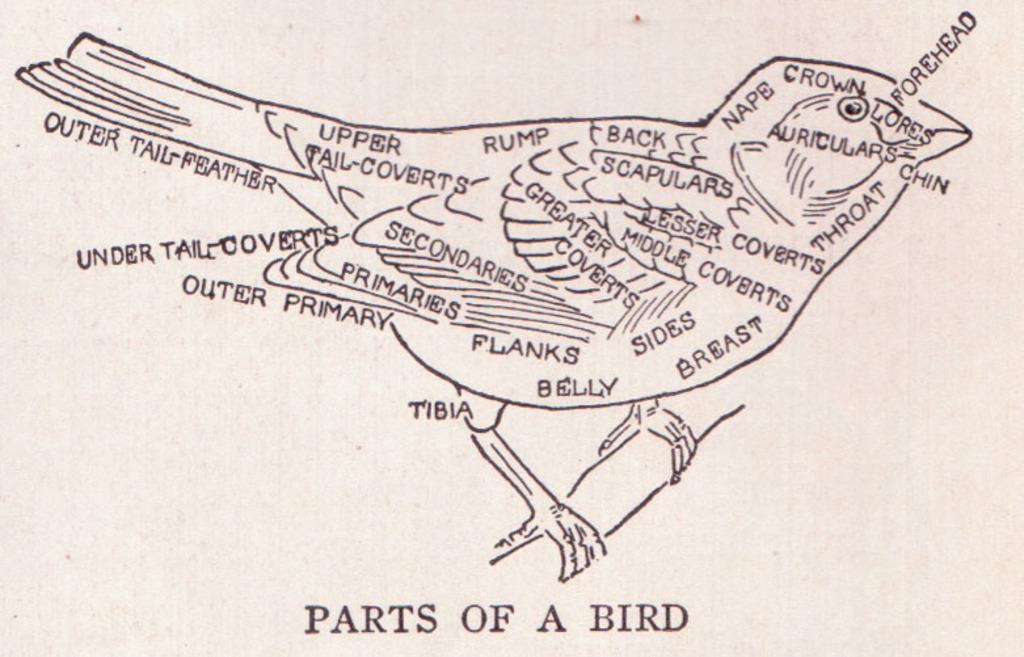What is featured on the poster in the image? The poster contains an art of a bird. What else can be found on the poster besides the bird art? There is text on the poster. How many trucks are visible in the image? There are no trucks present in the image. What type of cherry is being used as a prop in the image? There is no cherry present in the image. 